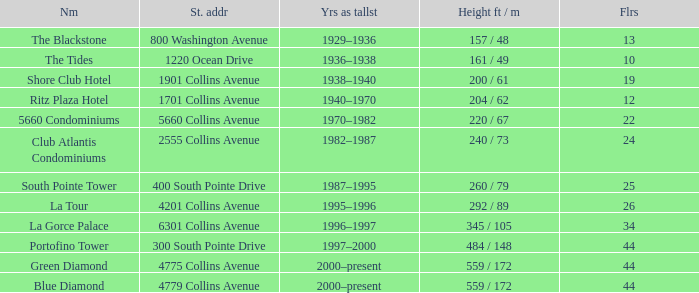How many years was the building with 24 floors the tallest? 1982–1987. 